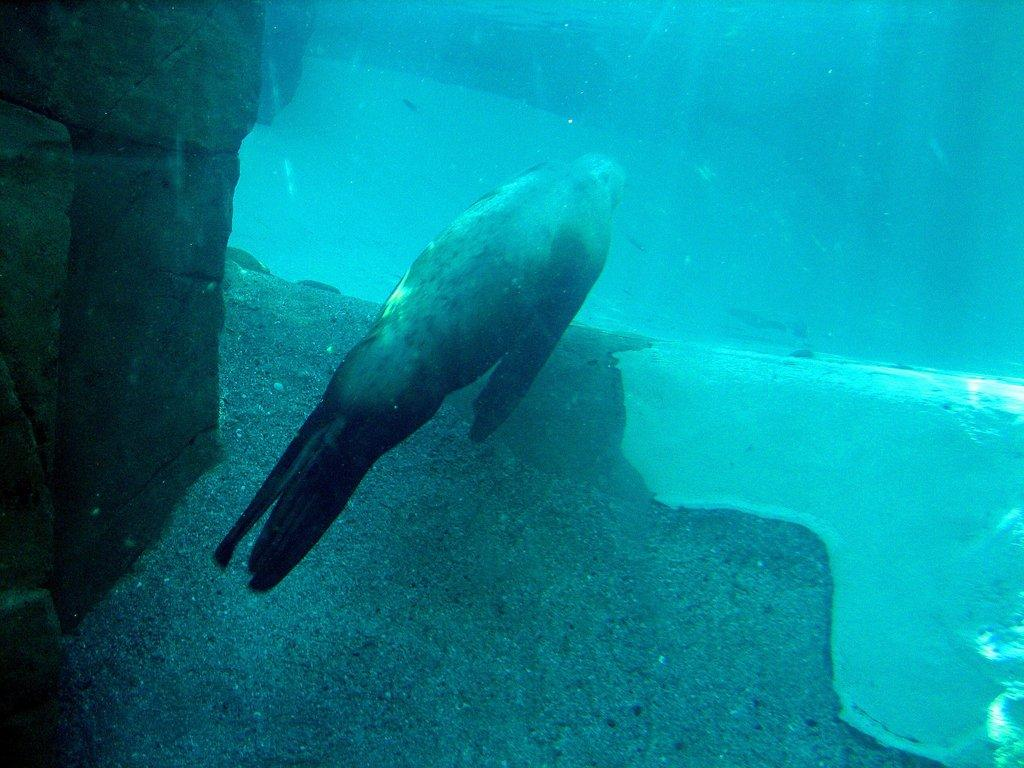What is the perspective of the image? The image shows a view inside the water. What can be seen in the water besides the fish? There are rocks visible in the water. What type of animal is present in the water? There is a fish in the water. What physical features does the fish have? The fish has fins and a tail. What is the fish's behavior in relation to the list in the image? There is no list present in the image, and therefore the fish's behavior in relation to it cannot be determined. 